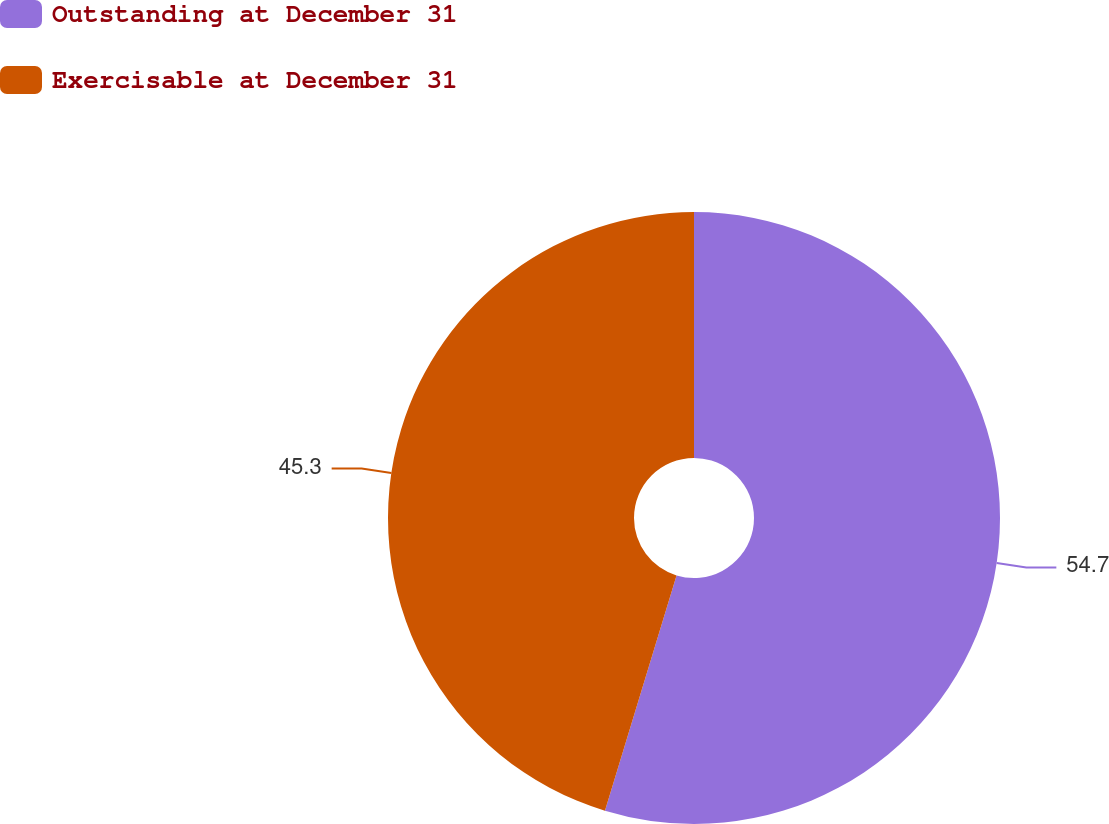Convert chart. <chart><loc_0><loc_0><loc_500><loc_500><pie_chart><fcel>Outstanding at December 31<fcel>Exercisable at December 31<nl><fcel>54.7%<fcel>45.3%<nl></chart> 